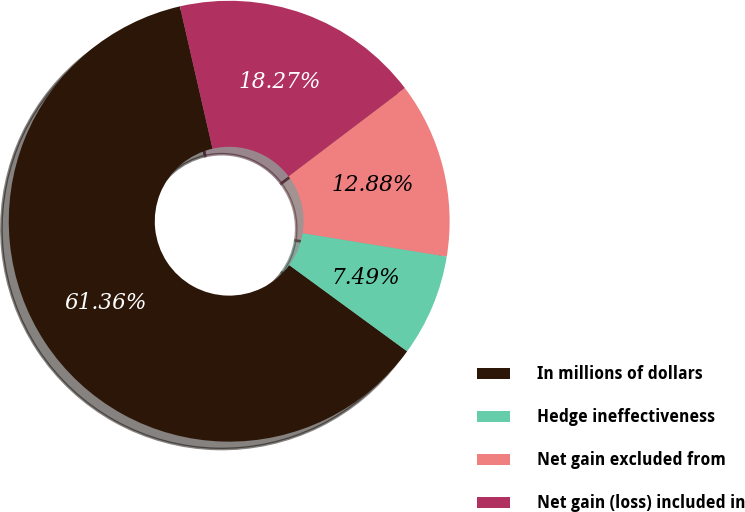<chart> <loc_0><loc_0><loc_500><loc_500><pie_chart><fcel>In millions of dollars<fcel>Hedge ineffectiveness<fcel>Net gain excluded from<fcel>Net gain (loss) included in<nl><fcel>61.36%<fcel>7.49%<fcel>12.88%<fcel>18.27%<nl></chart> 